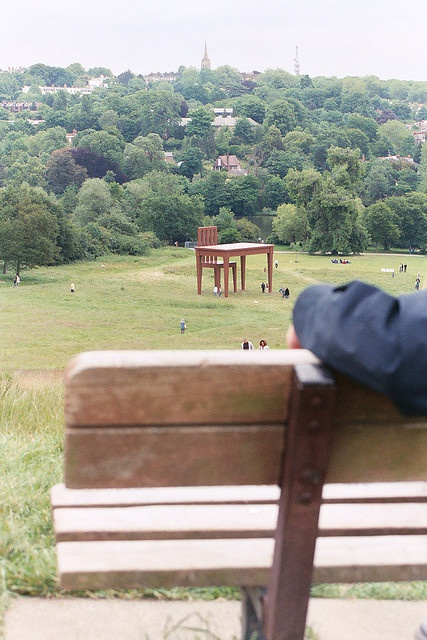Describe the objects in this image and their specific colors. I can see bench in white, gray, brown, and black tones, people in white, gray, black, and navy tones, dining table in white, brown, and maroon tones, chair in white, brown, and maroon tones, and people in white, black, gray, and darkgray tones in this image. 